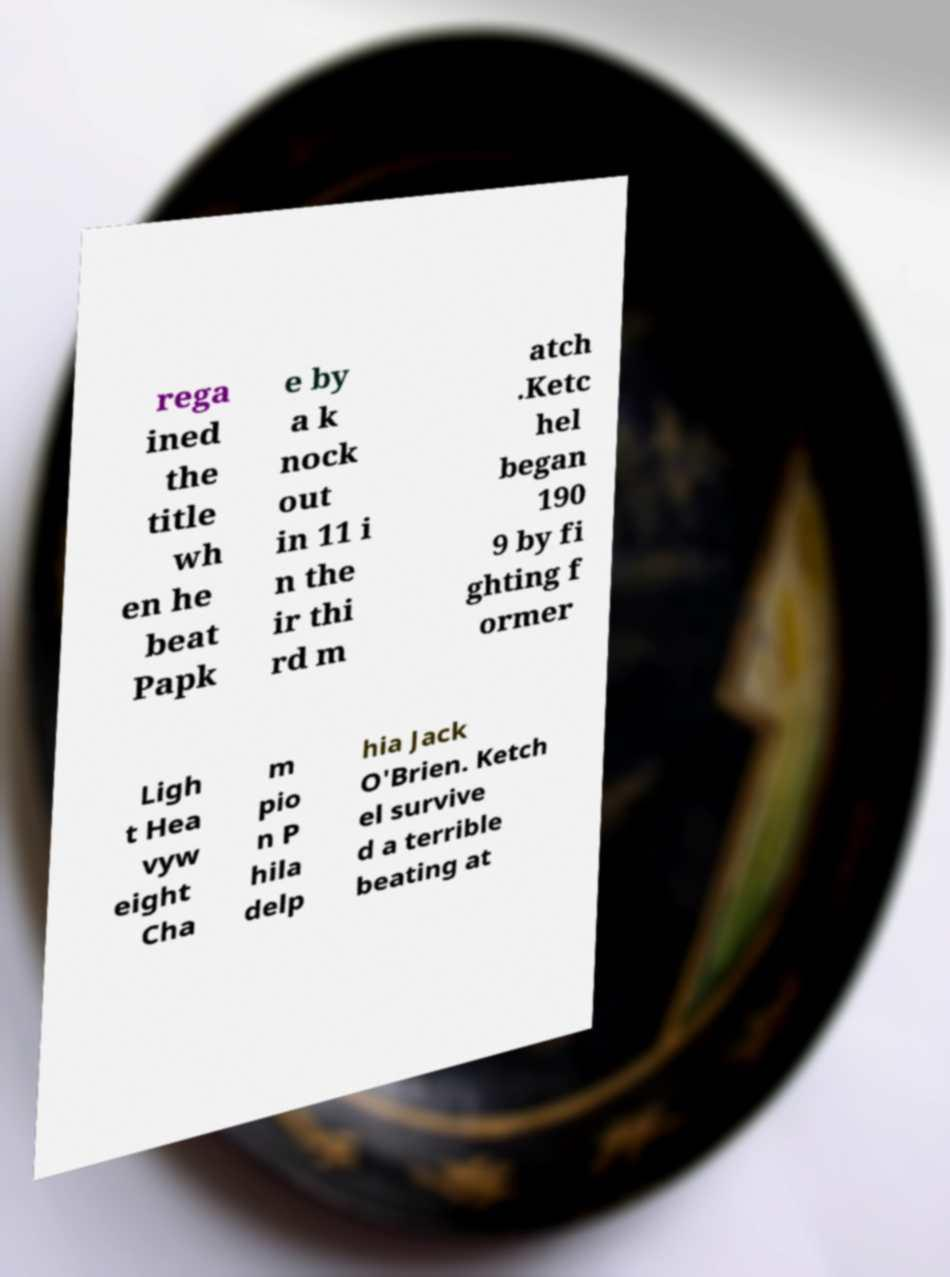There's text embedded in this image that I need extracted. Can you transcribe it verbatim? rega ined the title wh en he beat Papk e by a k nock out in 11 i n the ir thi rd m atch .Ketc hel began 190 9 by fi ghting f ormer Ligh t Hea vyw eight Cha m pio n P hila delp hia Jack O'Brien. Ketch el survive d a terrible beating at 